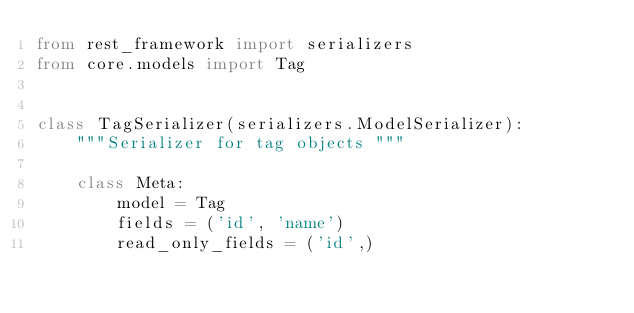Convert code to text. <code><loc_0><loc_0><loc_500><loc_500><_Python_>from rest_framework import serializers
from core.models import Tag


class TagSerializer(serializers.ModelSerializer):
    """Serializer for tag objects """

    class Meta:
        model = Tag
        fields = ('id', 'name')
        read_only_fields = ('id',)
</code> 